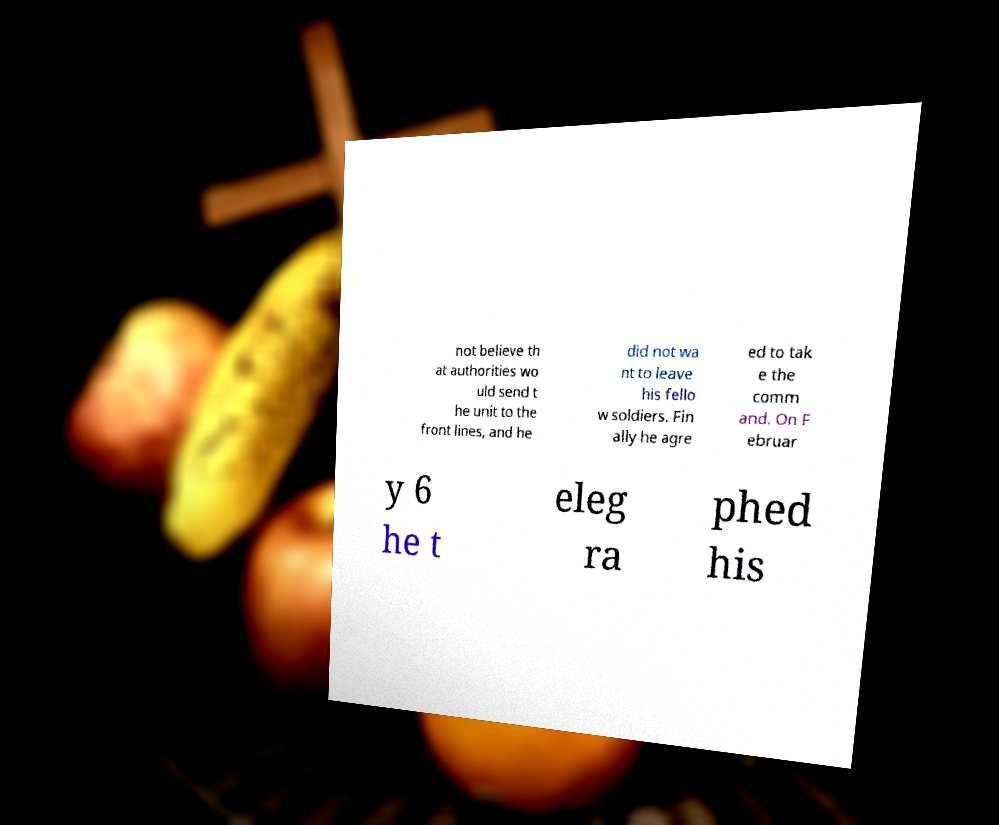Can you read and provide the text displayed in the image?This photo seems to have some interesting text. Can you extract and type it out for me? not believe th at authorities wo uld send t he unit to the front lines, and he did not wa nt to leave his fello w soldiers. Fin ally he agre ed to tak e the comm and. On F ebruar y 6 he t eleg ra phed his 